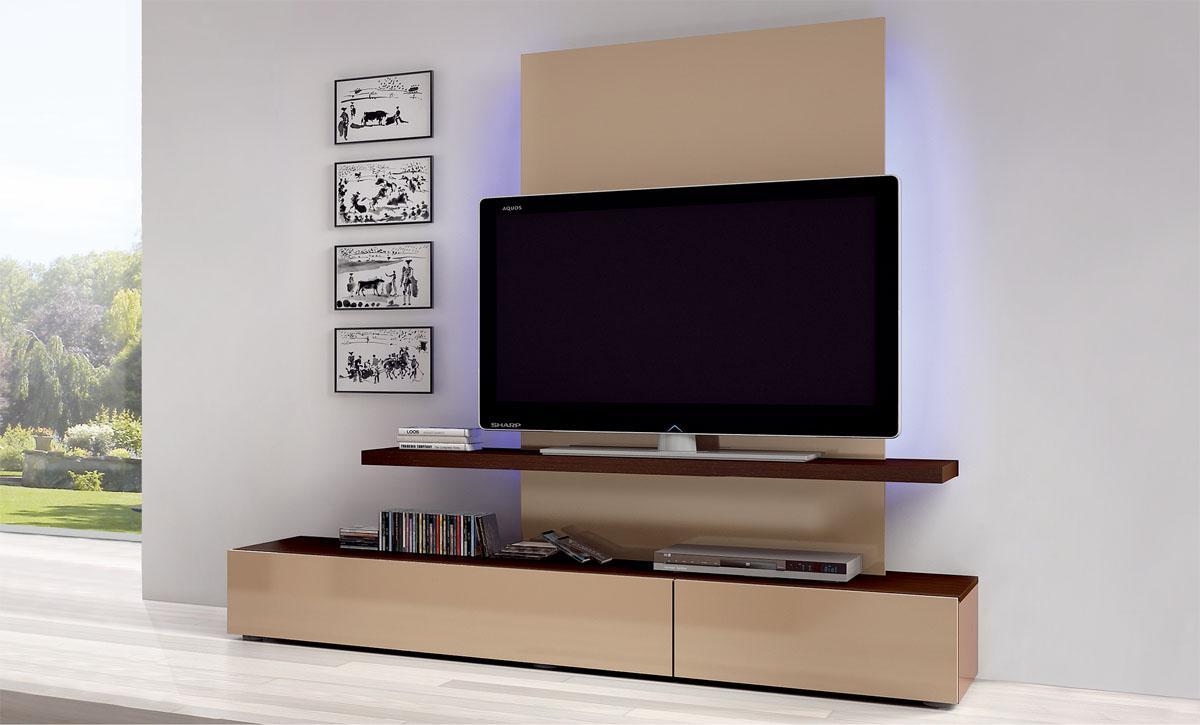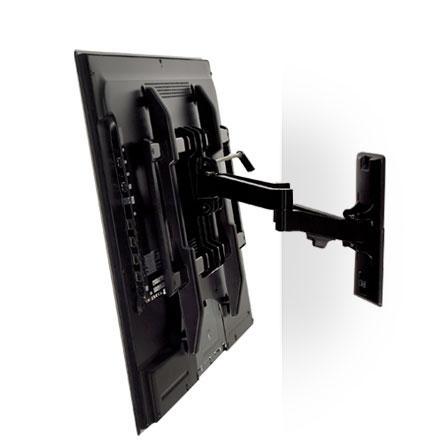The first image is the image on the left, the second image is the image on the right. Examine the images to the left and right. Is the description "In the left image a television is attached to the wall." accurate? Answer yes or no. No. The first image is the image on the left, the second image is the image on the right. Assess this claim about the two images: "The right image shows a side-view of a TV on a pivoting wall-mounted arm, and the left image shows a TV screen above a narrow shelf.". Correct or not? Answer yes or no. Yes. 